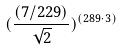Convert formula to latex. <formula><loc_0><loc_0><loc_500><loc_500>( \frac { ( 7 / 2 2 9 ) } { \sqrt { 2 } } ) ^ { ( 2 8 9 \cdot 3 ) }</formula> 